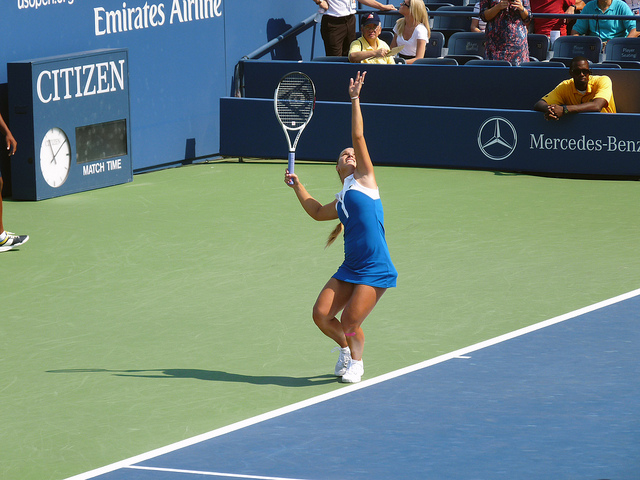<image>What letter is on the racket? I don't know what letter is on the racket. It could be '0', 'v', 'e', '9', 'b', 'p', 'w', or there might be no letter at all. What letter is on the racket? I am not sure what letter is on the racket. It can be seen '0', 'v', 'e', '9', 'b', 'p', or 'w'. 